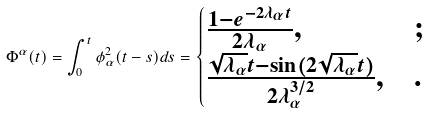Convert formula to latex. <formula><loc_0><loc_0><loc_500><loc_500>\Phi ^ { \alpha } ( t ) = \int _ { 0 } ^ { t } \phi _ { \alpha } ^ { 2 } ( t - s ) d s = \begin{cases} \frac { 1 - e ^ { - 2 \lambda _ { \alpha } t } } { 2 \lambda _ { \alpha } } , & ; \\ \frac { \sqrt { \lambda _ { \alpha } } t - \sin ( 2 \sqrt { \lambda _ { \alpha } } t ) } { 2 \lambda _ { \alpha } ^ { 3 / 2 } } , & . \end{cases}</formula> 